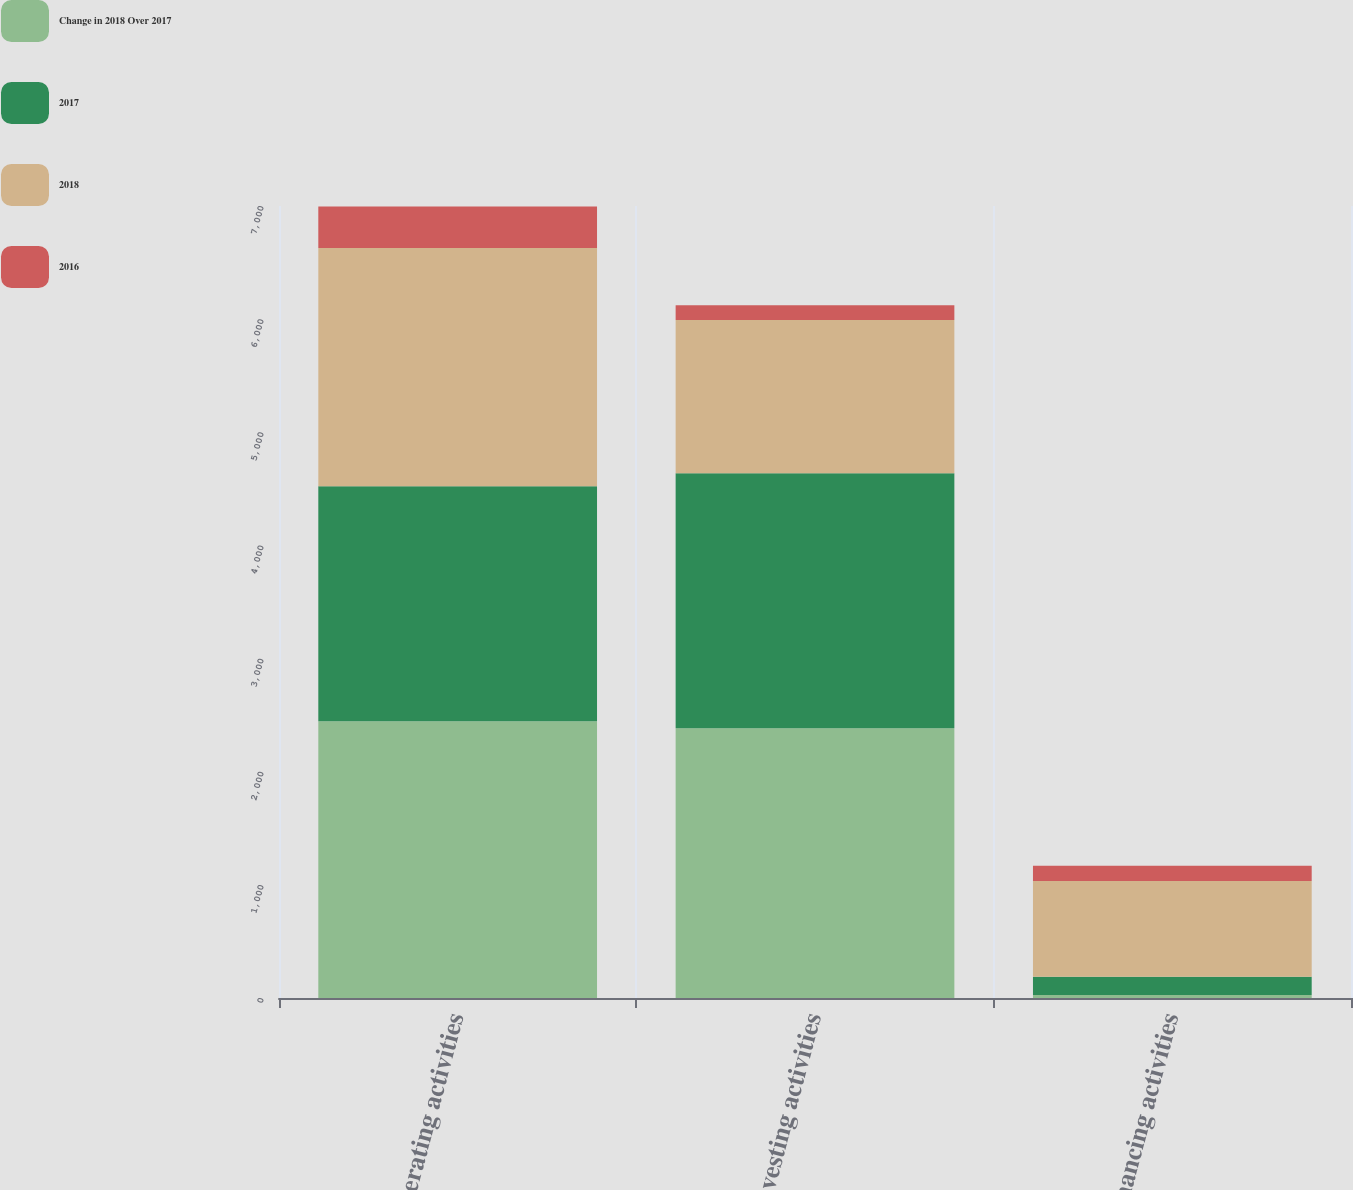<chart> <loc_0><loc_0><loc_500><loc_500><stacked_bar_chart><ecel><fcel>Operating activities<fcel>Investing activities<fcel>Financing activities<nl><fcel>Change in 2018 Over 2017<fcel>2445.5<fcel>2384.4<fcel>26.4<nl><fcel>2017<fcel>2078.6<fcel>2254.1<fcel>161.4<nl><fcel>2018<fcel>2103.8<fcel>1354.2<fcel>845.7<nl><fcel>2016<fcel>366.9<fcel>130.3<fcel>135<nl></chart> 